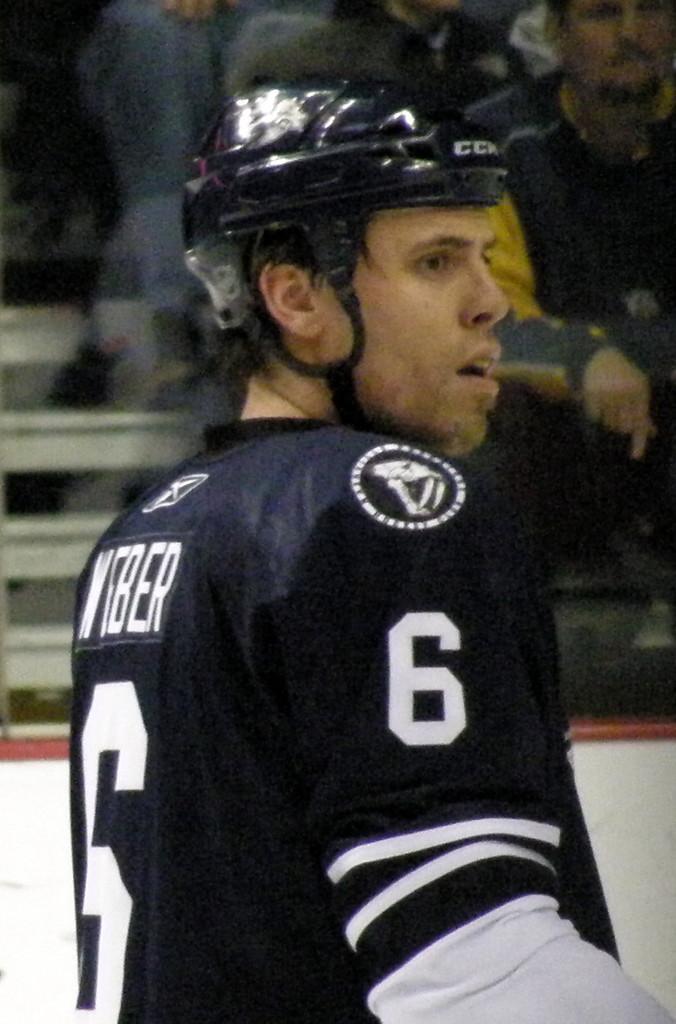How would you summarize this image in a sentence or two? In this picture there is a man who is wearing helmet and six number jersey. In the background we can see the group of persons sitting on the stairs and watching the game. 